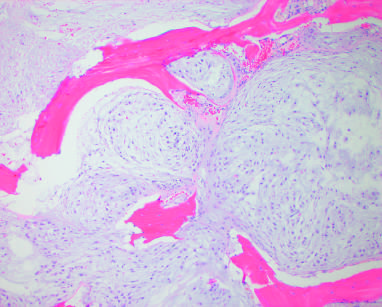does the surrounding lung entrap native lamellar bone as a confluent mass of cartilage?
Answer the question using a single word or phrase. No 